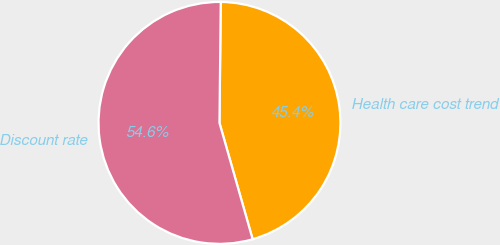Convert chart. <chart><loc_0><loc_0><loc_500><loc_500><pie_chart><fcel>Health care cost trend<fcel>Discount rate<nl><fcel>45.41%<fcel>54.59%<nl></chart> 